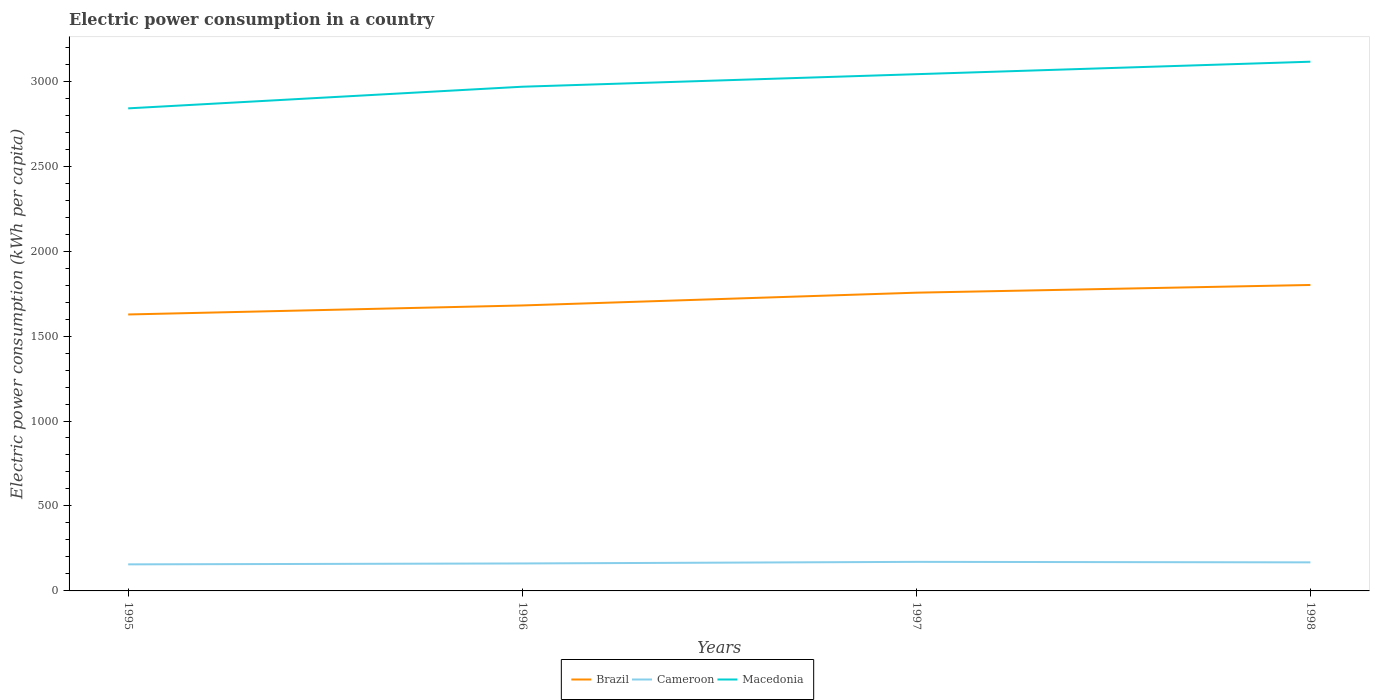How many different coloured lines are there?
Offer a terse response. 3. Does the line corresponding to Brazil intersect with the line corresponding to Cameroon?
Keep it short and to the point. No. Is the number of lines equal to the number of legend labels?
Provide a short and direct response. Yes. Across all years, what is the maximum electric power consumption in in Macedonia?
Your answer should be very brief. 2839.97. In which year was the electric power consumption in in Brazil maximum?
Provide a succinct answer. 1995. What is the total electric power consumption in in Brazil in the graph?
Offer a terse response. -53.04. What is the difference between the highest and the second highest electric power consumption in in Macedonia?
Ensure brevity in your answer.  274.57. What is the difference between the highest and the lowest electric power consumption in in Macedonia?
Provide a succinct answer. 2. Is the electric power consumption in in Macedonia strictly greater than the electric power consumption in in Cameroon over the years?
Offer a very short reply. No. How many years are there in the graph?
Give a very brief answer. 4. Are the values on the major ticks of Y-axis written in scientific E-notation?
Ensure brevity in your answer.  No. How are the legend labels stacked?
Your answer should be compact. Horizontal. What is the title of the graph?
Your answer should be very brief. Electric power consumption in a country. What is the label or title of the Y-axis?
Your answer should be compact. Electric power consumption (kWh per capita). What is the Electric power consumption (kWh per capita) in Brazil in 1995?
Keep it short and to the point. 1627.02. What is the Electric power consumption (kWh per capita) in Cameroon in 1995?
Ensure brevity in your answer.  156.29. What is the Electric power consumption (kWh per capita) of Macedonia in 1995?
Offer a terse response. 2839.97. What is the Electric power consumption (kWh per capita) of Brazil in 1996?
Provide a succinct answer. 1680.06. What is the Electric power consumption (kWh per capita) of Cameroon in 1996?
Your answer should be compact. 161.62. What is the Electric power consumption (kWh per capita) of Macedonia in 1996?
Give a very brief answer. 2967.37. What is the Electric power consumption (kWh per capita) in Brazil in 1997?
Provide a short and direct response. 1755.22. What is the Electric power consumption (kWh per capita) of Cameroon in 1997?
Keep it short and to the point. 171.04. What is the Electric power consumption (kWh per capita) of Macedonia in 1997?
Your answer should be very brief. 3041.11. What is the Electric power consumption (kWh per capita) of Brazil in 1998?
Your response must be concise. 1800.59. What is the Electric power consumption (kWh per capita) of Cameroon in 1998?
Provide a succinct answer. 168.05. What is the Electric power consumption (kWh per capita) of Macedonia in 1998?
Give a very brief answer. 3114.54. Across all years, what is the maximum Electric power consumption (kWh per capita) of Brazil?
Make the answer very short. 1800.59. Across all years, what is the maximum Electric power consumption (kWh per capita) of Cameroon?
Offer a very short reply. 171.04. Across all years, what is the maximum Electric power consumption (kWh per capita) of Macedonia?
Offer a terse response. 3114.54. Across all years, what is the minimum Electric power consumption (kWh per capita) of Brazil?
Make the answer very short. 1627.02. Across all years, what is the minimum Electric power consumption (kWh per capita) of Cameroon?
Provide a short and direct response. 156.29. Across all years, what is the minimum Electric power consumption (kWh per capita) of Macedonia?
Offer a terse response. 2839.97. What is the total Electric power consumption (kWh per capita) in Brazil in the graph?
Give a very brief answer. 6862.88. What is the total Electric power consumption (kWh per capita) in Cameroon in the graph?
Make the answer very short. 657. What is the total Electric power consumption (kWh per capita) in Macedonia in the graph?
Ensure brevity in your answer.  1.20e+04. What is the difference between the Electric power consumption (kWh per capita) of Brazil in 1995 and that in 1996?
Your response must be concise. -53.04. What is the difference between the Electric power consumption (kWh per capita) of Cameroon in 1995 and that in 1996?
Ensure brevity in your answer.  -5.34. What is the difference between the Electric power consumption (kWh per capita) of Macedonia in 1995 and that in 1996?
Offer a terse response. -127.4. What is the difference between the Electric power consumption (kWh per capita) in Brazil in 1995 and that in 1997?
Offer a terse response. -128.21. What is the difference between the Electric power consumption (kWh per capita) in Cameroon in 1995 and that in 1997?
Ensure brevity in your answer.  -14.75. What is the difference between the Electric power consumption (kWh per capita) in Macedonia in 1995 and that in 1997?
Offer a very short reply. -201.15. What is the difference between the Electric power consumption (kWh per capita) of Brazil in 1995 and that in 1998?
Your response must be concise. -173.57. What is the difference between the Electric power consumption (kWh per capita) in Cameroon in 1995 and that in 1998?
Offer a very short reply. -11.76. What is the difference between the Electric power consumption (kWh per capita) of Macedonia in 1995 and that in 1998?
Your answer should be very brief. -274.57. What is the difference between the Electric power consumption (kWh per capita) of Brazil in 1996 and that in 1997?
Give a very brief answer. -75.16. What is the difference between the Electric power consumption (kWh per capita) in Cameroon in 1996 and that in 1997?
Give a very brief answer. -9.42. What is the difference between the Electric power consumption (kWh per capita) of Macedonia in 1996 and that in 1997?
Your response must be concise. -73.75. What is the difference between the Electric power consumption (kWh per capita) in Brazil in 1996 and that in 1998?
Your response must be concise. -120.53. What is the difference between the Electric power consumption (kWh per capita) in Cameroon in 1996 and that in 1998?
Your answer should be compact. -6.43. What is the difference between the Electric power consumption (kWh per capita) in Macedonia in 1996 and that in 1998?
Your answer should be very brief. -147.17. What is the difference between the Electric power consumption (kWh per capita) of Brazil in 1997 and that in 1998?
Ensure brevity in your answer.  -45.37. What is the difference between the Electric power consumption (kWh per capita) in Cameroon in 1997 and that in 1998?
Give a very brief answer. 2.99. What is the difference between the Electric power consumption (kWh per capita) of Macedonia in 1997 and that in 1998?
Keep it short and to the point. -73.43. What is the difference between the Electric power consumption (kWh per capita) of Brazil in 1995 and the Electric power consumption (kWh per capita) of Cameroon in 1996?
Make the answer very short. 1465.39. What is the difference between the Electric power consumption (kWh per capita) in Brazil in 1995 and the Electric power consumption (kWh per capita) in Macedonia in 1996?
Your answer should be compact. -1340.35. What is the difference between the Electric power consumption (kWh per capita) in Cameroon in 1995 and the Electric power consumption (kWh per capita) in Macedonia in 1996?
Offer a terse response. -2811.08. What is the difference between the Electric power consumption (kWh per capita) in Brazil in 1995 and the Electric power consumption (kWh per capita) in Cameroon in 1997?
Provide a succinct answer. 1455.97. What is the difference between the Electric power consumption (kWh per capita) of Brazil in 1995 and the Electric power consumption (kWh per capita) of Macedonia in 1997?
Make the answer very short. -1414.1. What is the difference between the Electric power consumption (kWh per capita) in Cameroon in 1995 and the Electric power consumption (kWh per capita) in Macedonia in 1997?
Offer a very short reply. -2884.83. What is the difference between the Electric power consumption (kWh per capita) in Brazil in 1995 and the Electric power consumption (kWh per capita) in Cameroon in 1998?
Provide a succinct answer. 1458.97. What is the difference between the Electric power consumption (kWh per capita) in Brazil in 1995 and the Electric power consumption (kWh per capita) in Macedonia in 1998?
Give a very brief answer. -1487.52. What is the difference between the Electric power consumption (kWh per capita) in Cameroon in 1995 and the Electric power consumption (kWh per capita) in Macedonia in 1998?
Your response must be concise. -2958.25. What is the difference between the Electric power consumption (kWh per capita) in Brazil in 1996 and the Electric power consumption (kWh per capita) in Cameroon in 1997?
Offer a very short reply. 1509.02. What is the difference between the Electric power consumption (kWh per capita) of Brazil in 1996 and the Electric power consumption (kWh per capita) of Macedonia in 1997?
Offer a terse response. -1361.05. What is the difference between the Electric power consumption (kWh per capita) in Cameroon in 1996 and the Electric power consumption (kWh per capita) in Macedonia in 1997?
Your response must be concise. -2879.49. What is the difference between the Electric power consumption (kWh per capita) of Brazil in 1996 and the Electric power consumption (kWh per capita) of Cameroon in 1998?
Make the answer very short. 1512.01. What is the difference between the Electric power consumption (kWh per capita) in Brazil in 1996 and the Electric power consumption (kWh per capita) in Macedonia in 1998?
Your response must be concise. -1434.48. What is the difference between the Electric power consumption (kWh per capita) of Cameroon in 1996 and the Electric power consumption (kWh per capita) of Macedonia in 1998?
Offer a very short reply. -2952.92. What is the difference between the Electric power consumption (kWh per capita) in Brazil in 1997 and the Electric power consumption (kWh per capita) in Cameroon in 1998?
Offer a very short reply. 1587.17. What is the difference between the Electric power consumption (kWh per capita) of Brazil in 1997 and the Electric power consumption (kWh per capita) of Macedonia in 1998?
Your answer should be very brief. -1359.32. What is the difference between the Electric power consumption (kWh per capita) in Cameroon in 1997 and the Electric power consumption (kWh per capita) in Macedonia in 1998?
Keep it short and to the point. -2943.5. What is the average Electric power consumption (kWh per capita) of Brazil per year?
Keep it short and to the point. 1715.72. What is the average Electric power consumption (kWh per capita) in Cameroon per year?
Offer a very short reply. 164.25. What is the average Electric power consumption (kWh per capita) of Macedonia per year?
Your answer should be compact. 2990.75. In the year 1995, what is the difference between the Electric power consumption (kWh per capita) in Brazil and Electric power consumption (kWh per capita) in Cameroon?
Provide a succinct answer. 1470.73. In the year 1995, what is the difference between the Electric power consumption (kWh per capita) in Brazil and Electric power consumption (kWh per capita) in Macedonia?
Ensure brevity in your answer.  -1212.95. In the year 1995, what is the difference between the Electric power consumption (kWh per capita) of Cameroon and Electric power consumption (kWh per capita) of Macedonia?
Ensure brevity in your answer.  -2683.68. In the year 1996, what is the difference between the Electric power consumption (kWh per capita) of Brazil and Electric power consumption (kWh per capita) of Cameroon?
Make the answer very short. 1518.43. In the year 1996, what is the difference between the Electric power consumption (kWh per capita) of Brazil and Electric power consumption (kWh per capita) of Macedonia?
Offer a very short reply. -1287.31. In the year 1996, what is the difference between the Electric power consumption (kWh per capita) of Cameroon and Electric power consumption (kWh per capita) of Macedonia?
Make the answer very short. -2805.74. In the year 1997, what is the difference between the Electric power consumption (kWh per capita) of Brazil and Electric power consumption (kWh per capita) of Cameroon?
Your answer should be very brief. 1584.18. In the year 1997, what is the difference between the Electric power consumption (kWh per capita) in Brazil and Electric power consumption (kWh per capita) in Macedonia?
Make the answer very short. -1285.89. In the year 1997, what is the difference between the Electric power consumption (kWh per capita) in Cameroon and Electric power consumption (kWh per capita) in Macedonia?
Provide a succinct answer. -2870.07. In the year 1998, what is the difference between the Electric power consumption (kWh per capita) of Brazil and Electric power consumption (kWh per capita) of Cameroon?
Give a very brief answer. 1632.54. In the year 1998, what is the difference between the Electric power consumption (kWh per capita) of Brazil and Electric power consumption (kWh per capita) of Macedonia?
Provide a succinct answer. -1313.95. In the year 1998, what is the difference between the Electric power consumption (kWh per capita) of Cameroon and Electric power consumption (kWh per capita) of Macedonia?
Ensure brevity in your answer.  -2946.49. What is the ratio of the Electric power consumption (kWh per capita) in Brazil in 1995 to that in 1996?
Ensure brevity in your answer.  0.97. What is the ratio of the Electric power consumption (kWh per capita) in Macedonia in 1995 to that in 1996?
Offer a very short reply. 0.96. What is the ratio of the Electric power consumption (kWh per capita) of Brazil in 1995 to that in 1997?
Offer a very short reply. 0.93. What is the ratio of the Electric power consumption (kWh per capita) in Cameroon in 1995 to that in 1997?
Provide a succinct answer. 0.91. What is the ratio of the Electric power consumption (kWh per capita) of Macedonia in 1995 to that in 1997?
Give a very brief answer. 0.93. What is the ratio of the Electric power consumption (kWh per capita) in Brazil in 1995 to that in 1998?
Make the answer very short. 0.9. What is the ratio of the Electric power consumption (kWh per capita) of Macedonia in 1995 to that in 1998?
Give a very brief answer. 0.91. What is the ratio of the Electric power consumption (kWh per capita) of Brazil in 1996 to that in 1997?
Give a very brief answer. 0.96. What is the ratio of the Electric power consumption (kWh per capita) in Cameroon in 1996 to that in 1997?
Give a very brief answer. 0.94. What is the ratio of the Electric power consumption (kWh per capita) of Macedonia in 1996 to that in 1997?
Offer a very short reply. 0.98. What is the ratio of the Electric power consumption (kWh per capita) of Brazil in 1996 to that in 1998?
Offer a terse response. 0.93. What is the ratio of the Electric power consumption (kWh per capita) of Cameroon in 1996 to that in 1998?
Your answer should be very brief. 0.96. What is the ratio of the Electric power consumption (kWh per capita) of Macedonia in 1996 to that in 1998?
Make the answer very short. 0.95. What is the ratio of the Electric power consumption (kWh per capita) of Brazil in 1997 to that in 1998?
Provide a short and direct response. 0.97. What is the ratio of the Electric power consumption (kWh per capita) of Cameroon in 1997 to that in 1998?
Your answer should be very brief. 1.02. What is the ratio of the Electric power consumption (kWh per capita) of Macedonia in 1997 to that in 1998?
Your answer should be compact. 0.98. What is the difference between the highest and the second highest Electric power consumption (kWh per capita) of Brazil?
Provide a succinct answer. 45.37. What is the difference between the highest and the second highest Electric power consumption (kWh per capita) of Cameroon?
Provide a short and direct response. 2.99. What is the difference between the highest and the second highest Electric power consumption (kWh per capita) of Macedonia?
Keep it short and to the point. 73.43. What is the difference between the highest and the lowest Electric power consumption (kWh per capita) of Brazil?
Your response must be concise. 173.57. What is the difference between the highest and the lowest Electric power consumption (kWh per capita) of Cameroon?
Your answer should be compact. 14.75. What is the difference between the highest and the lowest Electric power consumption (kWh per capita) in Macedonia?
Provide a short and direct response. 274.57. 